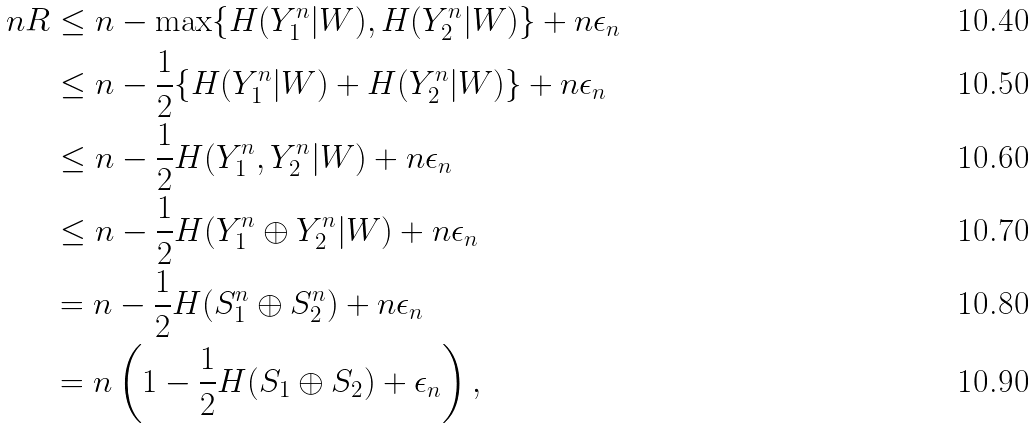Convert formula to latex. <formula><loc_0><loc_0><loc_500><loc_500>n R & \leq n - \max \{ H ( Y _ { 1 } ^ { n } | W ) , H ( Y _ { 2 } ^ { n } | W ) \} + n \epsilon _ { n } \\ & \leq n - \frac { 1 } { 2 } \{ H ( Y _ { 1 } ^ { n } | W ) + H ( Y _ { 2 } ^ { n } | W ) \} + n \epsilon _ { n } \\ & \leq n - \frac { 1 } { 2 } H ( Y _ { 1 } ^ { n } , Y _ { 2 } ^ { n } | W ) + n \epsilon _ { n } \\ & \leq n - \frac { 1 } { 2 } H ( Y _ { 1 } ^ { n } \oplus Y _ { 2 } ^ { n } | W ) + n \epsilon _ { n } \\ & = n - \frac { 1 } { 2 } H ( S _ { 1 } ^ { n } \oplus S _ { 2 } ^ { n } ) + n \epsilon _ { n } \\ & = n \left ( 1 - \frac { 1 } { 2 } H ( S _ { 1 } \oplus S _ { 2 } ) + \epsilon _ { n } \right ) ,</formula> 